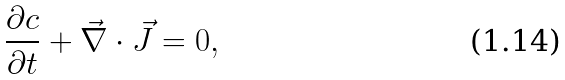Convert formula to latex. <formula><loc_0><loc_0><loc_500><loc_500>\frac { \partial c } { \partial t } + \vec { \nabla } \cdot \vec { J } = 0 ,</formula> 